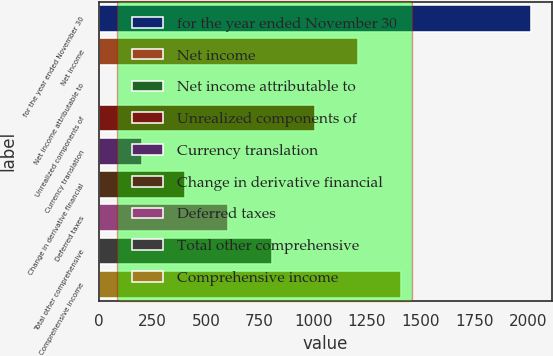Convert chart. <chart><loc_0><loc_0><loc_500><loc_500><bar_chart><fcel>for the year ended November 30<fcel>Net income<fcel>Net income attributable to<fcel>Unrealized components of<fcel>Currency translation<fcel>Change in derivative financial<fcel>Deferred taxes<fcel>Total other comprehensive<fcel>Comprehensive income<nl><fcel>2013<fcel>1208.32<fcel>1.3<fcel>1007.15<fcel>202.47<fcel>403.64<fcel>604.81<fcel>805.98<fcel>1409.49<nl></chart> 